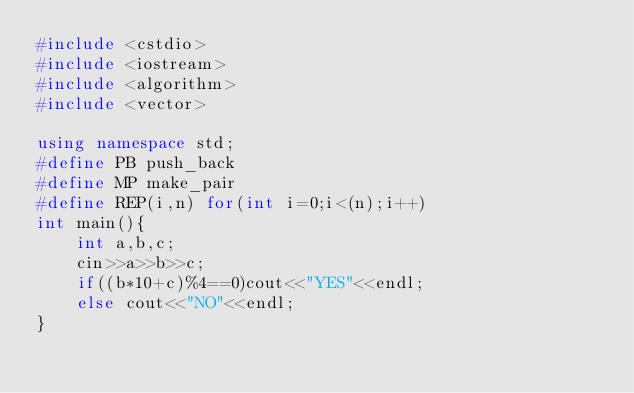Convert code to text. <code><loc_0><loc_0><loc_500><loc_500><_C++_>#include <cstdio>
#include <iostream>
#include <algorithm>
#include <vector>

using namespace std;
#define PB push_back
#define MP make_pair
#define REP(i,n) for(int i=0;i<(n);i++)
int main(){
    int a,b,c;
    cin>>a>>b>>c;
    if((b*10+c)%4==0)cout<<"YES"<<endl;
    else cout<<"NO"<<endl;
}</code> 